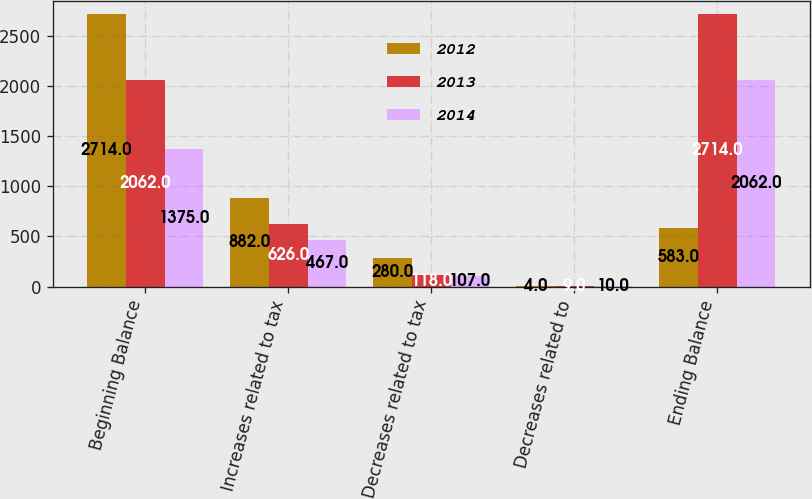Convert chart to OTSL. <chart><loc_0><loc_0><loc_500><loc_500><stacked_bar_chart><ecel><fcel>Beginning Balance<fcel>Increases related to tax<fcel>Decreases related to tax<fcel>Decreases related to<fcel>Ending Balance<nl><fcel>2012<fcel>2714<fcel>882<fcel>280<fcel>4<fcel>583<nl><fcel>2013<fcel>2062<fcel>626<fcel>118<fcel>9<fcel>2714<nl><fcel>2014<fcel>1375<fcel>467<fcel>107<fcel>10<fcel>2062<nl></chart> 